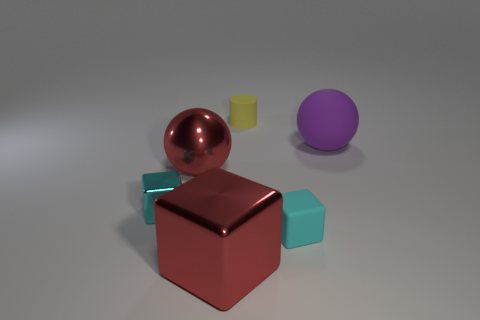Is there anything else that has the same shape as the yellow object?
Your answer should be very brief. No. What number of large objects are in front of the big purple sphere and right of the yellow matte thing?
Provide a succinct answer. 0. What is the material of the red block?
Keep it short and to the point. Metal. Are there the same number of metallic balls right of the cyan matte object and purple matte objects?
Your response must be concise. No. How many tiny cyan metallic things are the same shape as the large matte object?
Offer a very short reply. 0. Is the yellow object the same shape as the big purple object?
Your answer should be very brief. No. How many objects are either tiny matte things behind the big red sphere or big red rubber cylinders?
Provide a short and direct response. 1. There is a big metallic object on the left side of the metallic thing in front of the tiny cube that is right of the tiny shiny object; what shape is it?
Offer a terse response. Sphere. There is a cyan object that is made of the same material as the tiny yellow object; what is its shape?
Your response must be concise. Cube. The red cube is what size?
Ensure brevity in your answer.  Large. 